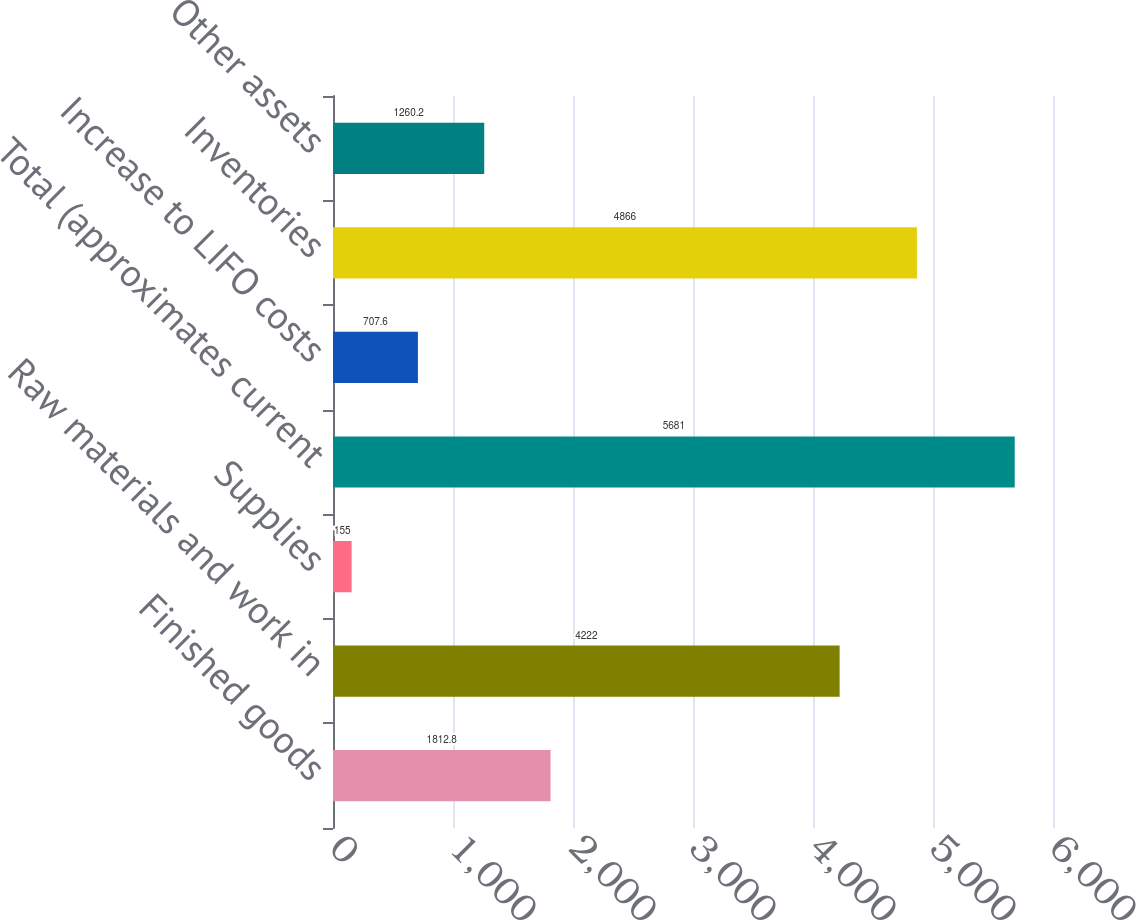Convert chart to OTSL. <chart><loc_0><loc_0><loc_500><loc_500><bar_chart><fcel>Finished goods<fcel>Raw materials and work in<fcel>Supplies<fcel>Total (approximates current<fcel>Increase to LIFO costs<fcel>Inventories<fcel>Other assets<nl><fcel>1812.8<fcel>4222<fcel>155<fcel>5681<fcel>707.6<fcel>4866<fcel>1260.2<nl></chart> 